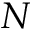<formula> <loc_0><loc_0><loc_500><loc_500>N</formula> 